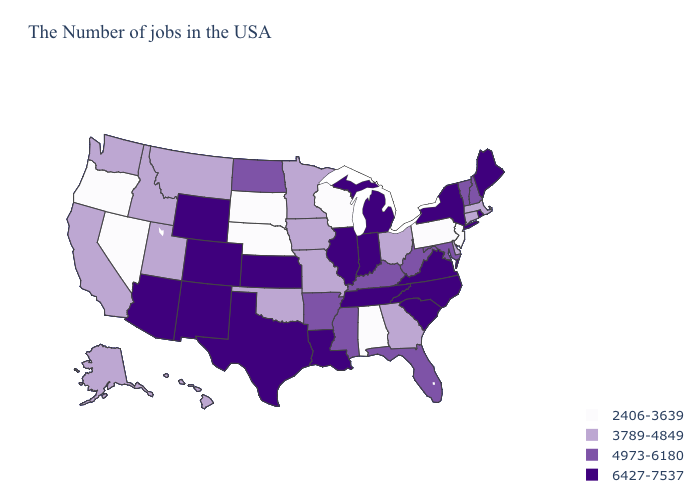What is the value of Arkansas?
Short answer required. 4973-6180. Does South Dakota have the highest value in the MidWest?
Write a very short answer. No. Name the states that have a value in the range 4973-6180?
Keep it brief. New Hampshire, Vermont, Maryland, West Virginia, Florida, Kentucky, Mississippi, Arkansas, North Dakota. Name the states that have a value in the range 3789-4849?
Give a very brief answer. Massachusetts, Connecticut, Delaware, Ohio, Georgia, Missouri, Minnesota, Iowa, Oklahoma, Utah, Montana, Idaho, California, Washington, Alaska, Hawaii. Does the first symbol in the legend represent the smallest category?
Write a very short answer. Yes. Name the states that have a value in the range 2406-3639?
Write a very short answer. New Jersey, Pennsylvania, Alabama, Wisconsin, Nebraska, South Dakota, Nevada, Oregon. What is the lowest value in the USA?
Give a very brief answer. 2406-3639. Name the states that have a value in the range 6427-7537?
Short answer required. Maine, Rhode Island, New York, Virginia, North Carolina, South Carolina, Michigan, Indiana, Tennessee, Illinois, Louisiana, Kansas, Texas, Wyoming, Colorado, New Mexico, Arizona. Name the states that have a value in the range 4973-6180?
Short answer required. New Hampshire, Vermont, Maryland, West Virginia, Florida, Kentucky, Mississippi, Arkansas, North Dakota. Name the states that have a value in the range 6427-7537?
Answer briefly. Maine, Rhode Island, New York, Virginia, North Carolina, South Carolina, Michigan, Indiana, Tennessee, Illinois, Louisiana, Kansas, Texas, Wyoming, Colorado, New Mexico, Arizona. What is the highest value in states that border Michigan?
Write a very short answer. 6427-7537. What is the lowest value in states that border Colorado?
Give a very brief answer. 2406-3639. Does Montana have a lower value than Maine?
Write a very short answer. Yes. Does Rhode Island have the highest value in the Northeast?
Short answer required. Yes. 